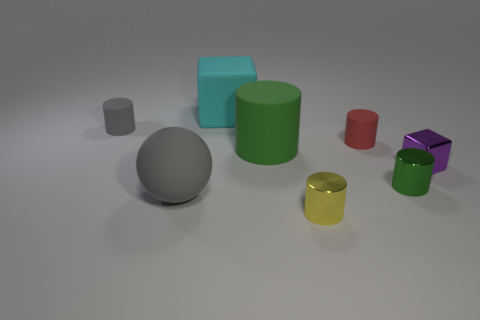What material is the tiny purple thing that is in front of the small matte thing left of the block behind the green matte cylinder?
Give a very brief answer. Metal. How many objects are big matte objects behind the big cylinder or small objects?
Your answer should be compact. 6. How many other objects are there of the same shape as the small red rubber thing?
Give a very brief answer. 4. Is the number of large green objects that are right of the tiny purple block greater than the number of small yellow shiny cubes?
Your answer should be compact. No. The yellow metal object that is the same shape as the red rubber object is what size?
Keep it short and to the point. Small. Are there any other things that have the same material as the tiny gray object?
Provide a succinct answer. Yes. What is the shape of the yellow thing?
Give a very brief answer. Cylinder. There is a green matte object that is the same size as the cyan rubber block; what shape is it?
Your response must be concise. Cylinder. Is there anything else of the same color as the tiny block?
Make the answer very short. No. What is the size of the green cylinder that is the same material as the purple object?
Provide a succinct answer. Small. 